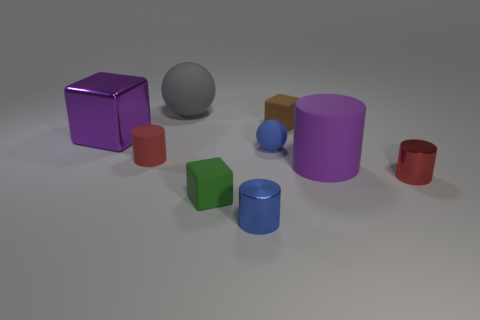Subtract all balls. How many objects are left? 7 Add 3 tiny brown rubber blocks. How many tiny brown rubber blocks are left? 4 Add 5 tiny red metallic things. How many tiny red metallic things exist? 6 Subtract 1 purple cylinders. How many objects are left? 8 Subtract all green things. Subtract all green matte things. How many objects are left? 7 